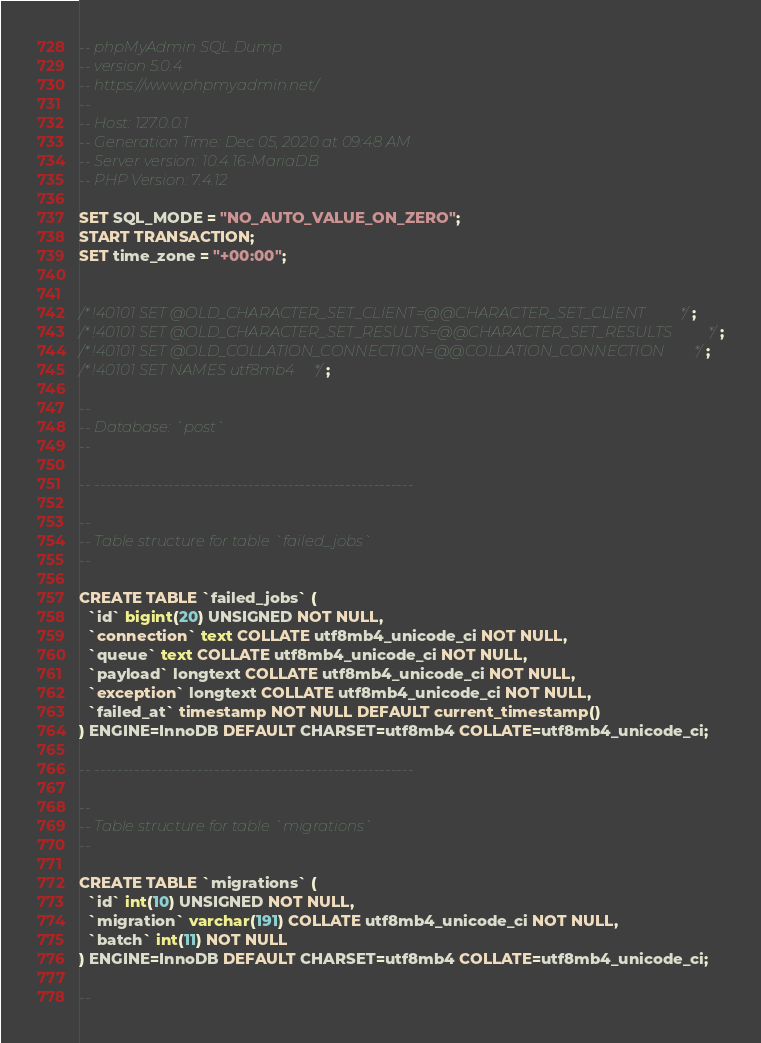<code> <loc_0><loc_0><loc_500><loc_500><_SQL_>-- phpMyAdmin SQL Dump
-- version 5.0.4
-- https://www.phpmyadmin.net/
--
-- Host: 127.0.0.1
-- Generation Time: Dec 05, 2020 at 09:48 AM
-- Server version: 10.4.16-MariaDB
-- PHP Version: 7.4.12

SET SQL_MODE = "NO_AUTO_VALUE_ON_ZERO";
START TRANSACTION;
SET time_zone = "+00:00";


/*!40101 SET @OLD_CHARACTER_SET_CLIENT=@@CHARACTER_SET_CLIENT */;
/*!40101 SET @OLD_CHARACTER_SET_RESULTS=@@CHARACTER_SET_RESULTS */;
/*!40101 SET @OLD_COLLATION_CONNECTION=@@COLLATION_CONNECTION */;
/*!40101 SET NAMES utf8mb4 */;

--
-- Database: `post`
--

-- --------------------------------------------------------

--
-- Table structure for table `failed_jobs`
--

CREATE TABLE `failed_jobs` (
  `id` bigint(20) UNSIGNED NOT NULL,
  `connection` text COLLATE utf8mb4_unicode_ci NOT NULL,
  `queue` text COLLATE utf8mb4_unicode_ci NOT NULL,
  `payload` longtext COLLATE utf8mb4_unicode_ci NOT NULL,
  `exception` longtext COLLATE utf8mb4_unicode_ci NOT NULL,
  `failed_at` timestamp NOT NULL DEFAULT current_timestamp()
) ENGINE=InnoDB DEFAULT CHARSET=utf8mb4 COLLATE=utf8mb4_unicode_ci;

-- --------------------------------------------------------

--
-- Table structure for table `migrations`
--

CREATE TABLE `migrations` (
  `id` int(10) UNSIGNED NOT NULL,
  `migration` varchar(191) COLLATE utf8mb4_unicode_ci NOT NULL,
  `batch` int(11) NOT NULL
) ENGINE=InnoDB DEFAULT CHARSET=utf8mb4 COLLATE=utf8mb4_unicode_ci;

--</code> 